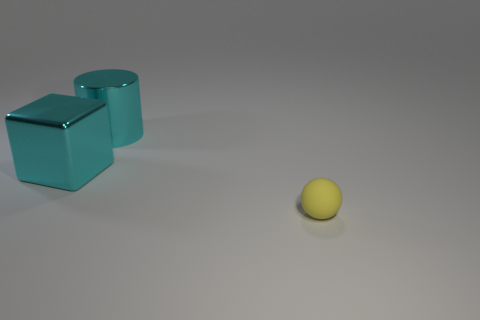Is there any other thing that has the same material as the ball?
Provide a short and direct response. No. What number of objects are yellow things or cyan cylinders?
Your answer should be very brief. 2. What is the shape of the cyan thing that is to the right of the big cyan thing that is in front of the large cyan cylinder?
Provide a succinct answer. Cylinder. What size is the cyan cylinder that is the same material as the cyan block?
Keep it short and to the point. Large. What number of things are things left of the sphere or cyan metal objects on the left side of the large cyan cylinder?
Ensure brevity in your answer.  2. Are there an equal number of cubes to the right of the large metallic cylinder and tiny rubber spheres left of the big cyan block?
Provide a short and direct response. Yes. There is a big shiny thing to the left of the big shiny cylinder; what color is it?
Give a very brief answer. Cyan. There is a cube; does it have the same color as the big metallic thing that is to the right of the large metal cube?
Your answer should be very brief. Yes. Is the number of big shiny cylinders less than the number of yellow cubes?
Ensure brevity in your answer.  No. Is the color of the shiny object to the right of the cube the same as the block?
Your answer should be compact. Yes. 